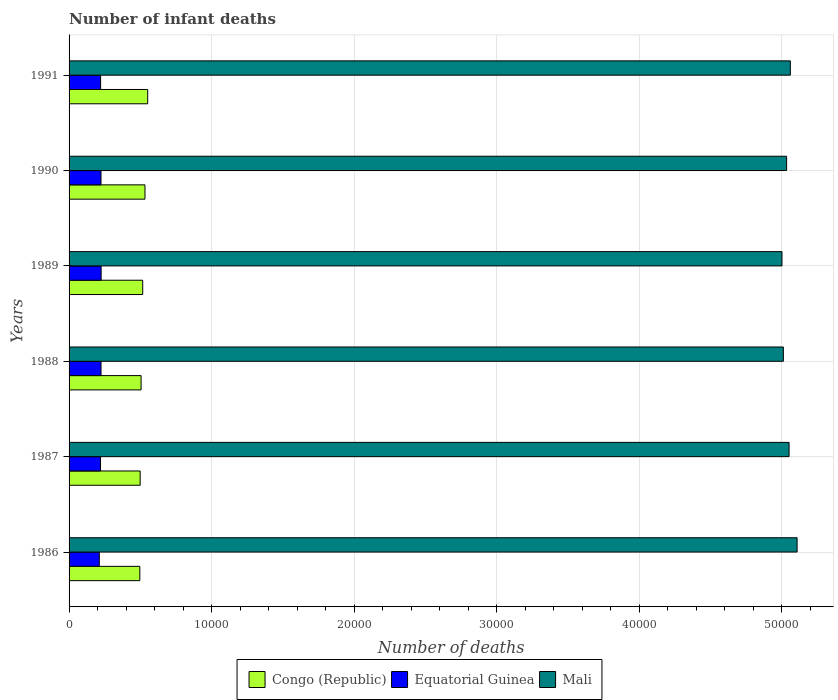How many different coloured bars are there?
Provide a succinct answer. 3. How many groups of bars are there?
Provide a succinct answer. 6. Are the number of bars per tick equal to the number of legend labels?
Provide a short and direct response. Yes. Are the number of bars on each tick of the Y-axis equal?
Ensure brevity in your answer.  Yes. How many bars are there on the 1st tick from the bottom?
Your answer should be very brief. 3. What is the label of the 5th group of bars from the top?
Give a very brief answer. 1987. In how many cases, is the number of bars for a given year not equal to the number of legend labels?
Provide a short and direct response. 0. What is the number of infant deaths in Congo (Republic) in 1988?
Your answer should be compact. 5053. Across all years, what is the maximum number of infant deaths in Mali?
Keep it short and to the point. 5.11e+04. Across all years, what is the minimum number of infant deaths in Equatorial Guinea?
Provide a succinct answer. 2121. In which year was the number of infant deaths in Mali maximum?
Provide a succinct answer. 1986. In which year was the number of infant deaths in Equatorial Guinea minimum?
Give a very brief answer. 1986. What is the total number of infant deaths in Mali in the graph?
Your answer should be compact. 3.03e+05. What is the difference between the number of infant deaths in Mali in 1987 and that in 1991?
Give a very brief answer. -88. What is the difference between the number of infant deaths in Congo (Republic) in 1990 and the number of infant deaths in Equatorial Guinea in 1987?
Keep it short and to the point. 3119. What is the average number of infant deaths in Mali per year?
Offer a very short reply. 5.04e+04. In the year 1991, what is the difference between the number of infant deaths in Mali and number of infant deaths in Equatorial Guinea?
Give a very brief answer. 4.84e+04. In how many years, is the number of infant deaths in Mali greater than 8000 ?
Give a very brief answer. 6. What is the ratio of the number of infant deaths in Mali in 1987 to that in 1989?
Your response must be concise. 1.01. Is the difference between the number of infant deaths in Mali in 1986 and 1990 greater than the difference between the number of infant deaths in Equatorial Guinea in 1986 and 1990?
Provide a short and direct response. Yes. What is the difference between the highest and the second highest number of infant deaths in Congo (Republic)?
Your answer should be very brief. 192. What is the difference between the highest and the lowest number of infant deaths in Equatorial Guinea?
Your response must be concise. 128. What does the 1st bar from the top in 1988 represents?
Keep it short and to the point. Mali. What does the 3rd bar from the bottom in 1988 represents?
Your answer should be compact. Mali. What is the difference between two consecutive major ticks on the X-axis?
Your answer should be very brief. 10000. Are the values on the major ticks of X-axis written in scientific E-notation?
Ensure brevity in your answer.  No. Does the graph contain any zero values?
Offer a terse response. No. Does the graph contain grids?
Your response must be concise. Yes. Where does the legend appear in the graph?
Provide a succinct answer. Bottom center. How many legend labels are there?
Ensure brevity in your answer.  3. How are the legend labels stacked?
Ensure brevity in your answer.  Horizontal. What is the title of the graph?
Your answer should be compact. Number of infant deaths. Does "Antigua and Barbuda" appear as one of the legend labels in the graph?
Give a very brief answer. No. What is the label or title of the X-axis?
Your answer should be compact. Number of deaths. What is the label or title of the Y-axis?
Your answer should be compact. Years. What is the Number of deaths in Congo (Republic) in 1986?
Ensure brevity in your answer.  4964. What is the Number of deaths in Equatorial Guinea in 1986?
Your response must be concise. 2121. What is the Number of deaths of Mali in 1986?
Provide a succinct answer. 5.11e+04. What is the Number of deaths of Congo (Republic) in 1987?
Provide a short and direct response. 4988. What is the Number of deaths of Equatorial Guinea in 1987?
Offer a very short reply. 2206. What is the Number of deaths of Mali in 1987?
Offer a very short reply. 5.05e+04. What is the Number of deaths in Congo (Republic) in 1988?
Your answer should be very brief. 5053. What is the Number of deaths in Equatorial Guinea in 1988?
Ensure brevity in your answer.  2243. What is the Number of deaths in Mali in 1988?
Make the answer very short. 5.01e+04. What is the Number of deaths of Congo (Republic) in 1989?
Your answer should be very brief. 5166. What is the Number of deaths of Equatorial Guinea in 1989?
Provide a succinct answer. 2249. What is the Number of deaths in Mali in 1989?
Your answer should be compact. 5.00e+04. What is the Number of deaths of Congo (Republic) in 1990?
Ensure brevity in your answer.  5325. What is the Number of deaths in Equatorial Guinea in 1990?
Make the answer very short. 2240. What is the Number of deaths in Mali in 1990?
Make the answer very short. 5.03e+04. What is the Number of deaths of Congo (Republic) in 1991?
Provide a succinct answer. 5517. What is the Number of deaths in Equatorial Guinea in 1991?
Ensure brevity in your answer.  2213. What is the Number of deaths in Mali in 1991?
Offer a terse response. 5.06e+04. Across all years, what is the maximum Number of deaths in Congo (Republic)?
Ensure brevity in your answer.  5517. Across all years, what is the maximum Number of deaths in Equatorial Guinea?
Keep it short and to the point. 2249. Across all years, what is the maximum Number of deaths of Mali?
Your answer should be compact. 5.11e+04. Across all years, what is the minimum Number of deaths of Congo (Republic)?
Offer a terse response. 4964. Across all years, what is the minimum Number of deaths in Equatorial Guinea?
Your answer should be compact. 2121. Across all years, what is the minimum Number of deaths in Mali?
Keep it short and to the point. 5.00e+04. What is the total Number of deaths of Congo (Republic) in the graph?
Offer a terse response. 3.10e+04. What is the total Number of deaths of Equatorial Guinea in the graph?
Provide a short and direct response. 1.33e+04. What is the total Number of deaths in Mali in the graph?
Make the answer very short. 3.03e+05. What is the difference between the Number of deaths of Congo (Republic) in 1986 and that in 1987?
Your response must be concise. -24. What is the difference between the Number of deaths of Equatorial Guinea in 1986 and that in 1987?
Ensure brevity in your answer.  -85. What is the difference between the Number of deaths of Mali in 1986 and that in 1987?
Offer a very short reply. 562. What is the difference between the Number of deaths in Congo (Republic) in 1986 and that in 1988?
Keep it short and to the point. -89. What is the difference between the Number of deaths of Equatorial Guinea in 1986 and that in 1988?
Provide a short and direct response. -122. What is the difference between the Number of deaths in Mali in 1986 and that in 1988?
Ensure brevity in your answer.  964. What is the difference between the Number of deaths of Congo (Republic) in 1986 and that in 1989?
Offer a terse response. -202. What is the difference between the Number of deaths in Equatorial Guinea in 1986 and that in 1989?
Your response must be concise. -128. What is the difference between the Number of deaths in Mali in 1986 and that in 1989?
Your answer should be compact. 1060. What is the difference between the Number of deaths in Congo (Republic) in 1986 and that in 1990?
Keep it short and to the point. -361. What is the difference between the Number of deaths in Equatorial Guinea in 1986 and that in 1990?
Give a very brief answer. -119. What is the difference between the Number of deaths of Mali in 1986 and that in 1990?
Your answer should be very brief. 734. What is the difference between the Number of deaths in Congo (Republic) in 1986 and that in 1991?
Provide a short and direct response. -553. What is the difference between the Number of deaths of Equatorial Guinea in 1986 and that in 1991?
Offer a terse response. -92. What is the difference between the Number of deaths of Mali in 1986 and that in 1991?
Make the answer very short. 474. What is the difference between the Number of deaths in Congo (Republic) in 1987 and that in 1988?
Your answer should be very brief. -65. What is the difference between the Number of deaths in Equatorial Guinea in 1987 and that in 1988?
Offer a terse response. -37. What is the difference between the Number of deaths of Mali in 1987 and that in 1988?
Provide a short and direct response. 402. What is the difference between the Number of deaths in Congo (Republic) in 1987 and that in 1989?
Offer a terse response. -178. What is the difference between the Number of deaths of Equatorial Guinea in 1987 and that in 1989?
Make the answer very short. -43. What is the difference between the Number of deaths in Mali in 1987 and that in 1989?
Your answer should be very brief. 498. What is the difference between the Number of deaths of Congo (Republic) in 1987 and that in 1990?
Provide a short and direct response. -337. What is the difference between the Number of deaths of Equatorial Guinea in 1987 and that in 1990?
Your answer should be compact. -34. What is the difference between the Number of deaths in Mali in 1987 and that in 1990?
Keep it short and to the point. 172. What is the difference between the Number of deaths of Congo (Republic) in 1987 and that in 1991?
Provide a succinct answer. -529. What is the difference between the Number of deaths in Equatorial Guinea in 1987 and that in 1991?
Your answer should be compact. -7. What is the difference between the Number of deaths in Mali in 1987 and that in 1991?
Give a very brief answer. -88. What is the difference between the Number of deaths of Congo (Republic) in 1988 and that in 1989?
Your response must be concise. -113. What is the difference between the Number of deaths in Equatorial Guinea in 1988 and that in 1989?
Offer a very short reply. -6. What is the difference between the Number of deaths of Mali in 1988 and that in 1989?
Your answer should be compact. 96. What is the difference between the Number of deaths in Congo (Republic) in 1988 and that in 1990?
Offer a terse response. -272. What is the difference between the Number of deaths of Mali in 1988 and that in 1990?
Provide a succinct answer. -230. What is the difference between the Number of deaths of Congo (Republic) in 1988 and that in 1991?
Make the answer very short. -464. What is the difference between the Number of deaths of Mali in 1988 and that in 1991?
Keep it short and to the point. -490. What is the difference between the Number of deaths of Congo (Republic) in 1989 and that in 1990?
Keep it short and to the point. -159. What is the difference between the Number of deaths of Mali in 1989 and that in 1990?
Provide a short and direct response. -326. What is the difference between the Number of deaths of Congo (Republic) in 1989 and that in 1991?
Offer a very short reply. -351. What is the difference between the Number of deaths of Equatorial Guinea in 1989 and that in 1991?
Provide a succinct answer. 36. What is the difference between the Number of deaths in Mali in 1989 and that in 1991?
Provide a short and direct response. -586. What is the difference between the Number of deaths in Congo (Republic) in 1990 and that in 1991?
Provide a succinct answer. -192. What is the difference between the Number of deaths of Mali in 1990 and that in 1991?
Provide a short and direct response. -260. What is the difference between the Number of deaths of Congo (Republic) in 1986 and the Number of deaths of Equatorial Guinea in 1987?
Make the answer very short. 2758. What is the difference between the Number of deaths in Congo (Republic) in 1986 and the Number of deaths in Mali in 1987?
Keep it short and to the point. -4.56e+04. What is the difference between the Number of deaths in Equatorial Guinea in 1986 and the Number of deaths in Mali in 1987?
Give a very brief answer. -4.84e+04. What is the difference between the Number of deaths in Congo (Republic) in 1986 and the Number of deaths in Equatorial Guinea in 1988?
Your answer should be compact. 2721. What is the difference between the Number of deaths of Congo (Republic) in 1986 and the Number of deaths of Mali in 1988?
Make the answer very short. -4.52e+04. What is the difference between the Number of deaths in Equatorial Guinea in 1986 and the Number of deaths in Mali in 1988?
Offer a terse response. -4.80e+04. What is the difference between the Number of deaths of Congo (Republic) in 1986 and the Number of deaths of Equatorial Guinea in 1989?
Make the answer very short. 2715. What is the difference between the Number of deaths of Congo (Republic) in 1986 and the Number of deaths of Mali in 1989?
Keep it short and to the point. -4.51e+04. What is the difference between the Number of deaths in Equatorial Guinea in 1986 and the Number of deaths in Mali in 1989?
Offer a terse response. -4.79e+04. What is the difference between the Number of deaths of Congo (Republic) in 1986 and the Number of deaths of Equatorial Guinea in 1990?
Your response must be concise. 2724. What is the difference between the Number of deaths of Congo (Republic) in 1986 and the Number of deaths of Mali in 1990?
Ensure brevity in your answer.  -4.54e+04. What is the difference between the Number of deaths in Equatorial Guinea in 1986 and the Number of deaths in Mali in 1990?
Ensure brevity in your answer.  -4.82e+04. What is the difference between the Number of deaths of Congo (Republic) in 1986 and the Number of deaths of Equatorial Guinea in 1991?
Make the answer very short. 2751. What is the difference between the Number of deaths in Congo (Republic) in 1986 and the Number of deaths in Mali in 1991?
Keep it short and to the point. -4.56e+04. What is the difference between the Number of deaths in Equatorial Guinea in 1986 and the Number of deaths in Mali in 1991?
Ensure brevity in your answer.  -4.85e+04. What is the difference between the Number of deaths of Congo (Republic) in 1987 and the Number of deaths of Equatorial Guinea in 1988?
Your answer should be compact. 2745. What is the difference between the Number of deaths in Congo (Republic) in 1987 and the Number of deaths in Mali in 1988?
Provide a short and direct response. -4.51e+04. What is the difference between the Number of deaths in Equatorial Guinea in 1987 and the Number of deaths in Mali in 1988?
Make the answer very short. -4.79e+04. What is the difference between the Number of deaths of Congo (Republic) in 1987 and the Number of deaths of Equatorial Guinea in 1989?
Your answer should be compact. 2739. What is the difference between the Number of deaths of Congo (Republic) in 1987 and the Number of deaths of Mali in 1989?
Provide a short and direct response. -4.50e+04. What is the difference between the Number of deaths in Equatorial Guinea in 1987 and the Number of deaths in Mali in 1989?
Keep it short and to the point. -4.78e+04. What is the difference between the Number of deaths of Congo (Republic) in 1987 and the Number of deaths of Equatorial Guinea in 1990?
Keep it short and to the point. 2748. What is the difference between the Number of deaths in Congo (Republic) in 1987 and the Number of deaths in Mali in 1990?
Offer a very short reply. -4.54e+04. What is the difference between the Number of deaths in Equatorial Guinea in 1987 and the Number of deaths in Mali in 1990?
Give a very brief answer. -4.81e+04. What is the difference between the Number of deaths in Congo (Republic) in 1987 and the Number of deaths in Equatorial Guinea in 1991?
Your answer should be compact. 2775. What is the difference between the Number of deaths of Congo (Republic) in 1987 and the Number of deaths of Mali in 1991?
Your response must be concise. -4.56e+04. What is the difference between the Number of deaths in Equatorial Guinea in 1987 and the Number of deaths in Mali in 1991?
Your response must be concise. -4.84e+04. What is the difference between the Number of deaths of Congo (Republic) in 1988 and the Number of deaths of Equatorial Guinea in 1989?
Make the answer very short. 2804. What is the difference between the Number of deaths of Congo (Republic) in 1988 and the Number of deaths of Mali in 1989?
Offer a terse response. -4.50e+04. What is the difference between the Number of deaths of Equatorial Guinea in 1988 and the Number of deaths of Mali in 1989?
Offer a terse response. -4.78e+04. What is the difference between the Number of deaths of Congo (Republic) in 1988 and the Number of deaths of Equatorial Guinea in 1990?
Your answer should be very brief. 2813. What is the difference between the Number of deaths in Congo (Republic) in 1988 and the Number of deaths in Mali in 1990?
Offer a terse response. -4.53e+04. What is the difference between the Number of deaths in Equatorial Guinea in 1988 and the Number of deaths in Mali in 1990?
Offer a very short reply. -4.81e+04. What is the difference between the Number of deaths of Congo (Republic) in 1988 and the Number of deaths of Equatorial Guinea in 1991?
Offer a terse response. 2840. What is the difference between the Number of deaths in Congo (Republic) in 1988 and the Number of deaths in Mali in 1991?
Your answer should be compact. -4.56e+04. What is the difference between the Number of deaths in Equatorial Guinea in 1988 and the Number of deaths in Mali in 1991?
Ensure brevity in your answer.  -4.84e+04. What is the difference between the Number of deaths of Congo (Republic) in 1989 and the Number of deaths of Equatorial Guinea in 1990?
Offer a very short reply. 2926. What is the difference between the Number of deaths in Congo (Republic) in 1989 and the Number of deaths in Mali in 1990?
Your response must be concise. -4.52e+04. What is the difference between the Number of deaths of Equatorial Guinea in 1989 and the Number of deaths of Mali in 1990?
Provide a short and direct response. -4.81e+04. What is the difference between the Number of deaths of Congo (Republic) in 1989 and the Number of deaths of Equatorial Guinea in 1991?
Your answer should be compact. 2953. What is the difference between the Number of deaths of Congo (Republic) in 1989 and the Number of deaths of Mali in 1991?
Make the answer very short. -4.54e+04. What is the difference between the Number of deaths of Equatorial Guinea in 1989 and the Number of deaths of Mali in 1991?
Your answer should be very brief. -4.84e+04. What is the difference between the Number of deaths of Congo (Republic) in 1990 and the Number of deaths of Equatorial Guinea in 1991?
Your response must be concise. 3112. What is the difference between the Number of deaths of Congo (Republic) in 1990 and the Number of deaths of Mali in 1991?
Your response must be concise. -4.53e+04. What is the difference between the Number of deaths in Equatorial Guinea in 1990 and the Number of deaths in Mali in 1991?
Offer a very short reply. -4.84e+04. What is the average Number of deaths of Congo (Republic) per year?
Your answer should be compact. 5168.83. What is the average Number of deaths of Equatorial Guinea per year?
Provide a succinct answer. 2212. What is the average Number of deaths of Mali per year?
Keep it short and to the point. 5.04e+04. In the year 1986, what is the difference between the Number of deaths in Congo (Republic) and Number of deaths in Equatorial Guinea?
Provide a short and direct response. 2843. In the year 1986, what is the difference between the Number of deaths of Congo (Republic) and Number of deaths of Mali?
Your answer should be very brief. -4.61e+04. In the year 1986, what is the difference between the Number of deaths of Equatorial Guinea and Number of deaths of Mali?
Keep it short and to the point. -4.90e+04. In the year 1987, what is the difference between the Number of deaths of Congo (Republic) and Number of deaths of Equatorial Guinea?
Offer a very short reply. 2782. In the year 1987, what is the difference between the Number of deaths of Congo (Republic) and Number of deaths of Mali?
Ensure brevity in your answer.  -4.55e+04. In the year 1987, what is the difference between the Number of deaths in Equatorial Guinea and Number of deaths in Mali?
Your response must be concise. -4.83e+04. In the year 1988, what is the difference between the Number of deaths of Congo (Republic) and Number of deaths of Equatorial Guinea?
Offer a very short reply. 2810. In the year 1988, what is the difference between the Number of deaths in Congo (Republic) and Number of deaths in Mali?
Your answer should be compact. -4.51e+04. In the year 1988, what is the difference between the Number of deaths in Equatorial Guinea and Number of deaths in Mali?
Give a very brief answer. -4.79e+04. In the year 1989, what is the difference between the Number of deaths in Congo (Republic) and Number of deaths in Equatorial Guinea?
Provide a succinct answer. 2917. In the year 1989, what is the difference between the Number of deaths in Congo (Republic) and Number of deaths in Mali?
Your answer should be compact. -4.49e+04. In the year 1989, what is the difference between the Number of deaths of Equatorial Guinea and Number of deaths of Mali?
Provide a short and direct response. -4.78e+04. In the year 1990, what is the difference between the Number of deaths in Congo (Republic) and Number of deaths in Equatorial Guinea?
Ensure brevity in your answer.  3085. In the year 1990, what is the difference between the Number of deaths of Congo (Republic) and Number of deaths of Mali?
Offer a terse response. -4.50e+04. In the year 1990, what is the difference between the Number of deaths of Equatorial Guinea and Number of deaths of Mali?
Ensure brevity in your answer.  -4.81e+04. In the year 1991, what is the difference between the Number of deaths in Congo (Republic) and Number of deaths in Equatorial Guinea?
Offer a very short reply. 3304. In the year 1991, what is the difference between the Number of deaths in Congo (Republic) and Number of deaths in Mali?
Offer a very short reply. -4.51e+04. In the year 1991, what is the difference between the Number of deaths of Equatorial Guinea and Number of deaths of Mali?
Offer a terse response. -4.84e+04. What is the ratio of the Number of deaths of Congo (Republic) in 1986 to that in 1987?
Your response must be concise. 1. What is the ratio of the Number of deaths in Equatorial Guinea in 1986 to that in 1987?
Provide a short and direct response. 0.96. What is the ratio of the Number of deaths in Mali in 1986 to that in 1987?
Your response must be concise. 1.01. What is the ratio of the Number of deaths in Congo (Republic) in 1986 to that in 1988?
Ensure brevity in your answer.  0.98. What is the ratio of the Number of deaths in Equatorial Guinea in 1986 to that in 1988?
Provide a succinct answer. 0.95. What is the ratio of the Number of deaths of Mali in 1986 to that in 1988?
Your answer should be very brief. 1.02. What is the ratio of the Number of deaths of Congo (Republic) in 1986 to that in 1989?
Offer a terse response. 0.96. What is the ratio of the Number of deaths in Equatorial Guinea in 1986 to that in 1989?
Offer a very short reply. 0.94. What is the ratio of the Number of deaths of Mali in 1986 to that in 1989?
Offer a terse response. 1.02. What is the ratio of the Number of deaths of Congo (Republic) in 1986 to that in 1990?
Offer a terse response. 0.93. What is the ratio of the Number of deaths of Equatorial Guinea in 1986 to that in 1990?
Keep it short and to the point. 0.95. What is the ratio of the Number of deaths in Mali in 1986 to that in 1990?
Ensure brevity in your answer.  1.01. What is the ratio of the Number of deaths in Congo (Republic) in 1986 to that in 1991?
Provide a short and direct response. 0.9. What is the ratio of the Number of deaths in Equatorial Guinea in 1986 to that in 1991?
Offer a terse response. 0.96. What is the ratio of the Number of deaths of Mali in 1986 to that in 1991?
Your response must be concise. 1.01. What is the ratio of the Number of deaths of Congo (Republic) in 1987 to that in 1988?
Ensure brevity in your answer.  0.99. What is the ratio of the Number of deaths of Equatorial Guinea in 1987 to that in 1988?
Provide a succinct answer. 0.98. What is the ratio of the Number of deaths in Congo (Republic) in 1987 to that in 1989?
Give a very brief answer. 0.97. What is the ratio of the Number of deaths of Equatorial Guinea in 1987 to that in 1989?
Give a very brief answer. 0.98. What is the ratio of the Number of deaths of Mali in 1987 to that in 1989?
Your answer should be compact. 1.01. What is the ratio of the Number of deaths in Congo (Republic) in 1987 to that in 1990?
Make the answer very short. 0.94. What is the ratio of the Number of deaths of Equatorial Guinea in 1987 to that in 1990?
Provide a short and direct response. 0.98. What is the ratio of the Number of deaths of Mali in 1987 to that in 1990?
Your response must be concise. 1. What is the ratio of the Number of deaths in Congo (Republic) in 1987 to that in 1991?
Your answer should be compact. 0.9. What is the ratio of the Number of deaths in Equatorial Guinea in 1987 to that in 1991?
Your response must be concise. 1. What is the ratio of the Number of deaths of Congo (Republic) in 1988 to that in 1989?
Your answer should be compact. 0.98. What is the ratio of the Number of deaths of Mali in 1988 to that in 1989?
Give a very brief answer. 1. What is the ratio of the Number of deaths of Congo (Republic) in 1988 to that in 1990?
Give a very brief answer. 0.95. What is the ratio of the Number of deaths of Equatorial Guinea in 1988 to that in 1990?
Your answer should be compact. 1. What is the ratio of the Number of deaths in Congo (Republic) in 1988 to that in 1991?
Provide a short and direct response. 0.92. What is the ratio of the Number of deaths of Equatorial Guinea in 1988 to that in 1991?
Provide a succinct answer. 1.01. What is the ratio of the Number of deaths in Mali in 1988 to that in 1991?
Give a very brief answer. 0.99. What is the ratio of the Number of deaths of Congo (Republic) in 1989 to that in 1990?
Offer a very short reply. 0.97. What is the ratio of the Number of deaths in Equatorial Guinea in 1989 to that in 1990?
Your answer should be compact. 1. What is the ratio of the Number of deaths in Mali in 1989 to that in 1990?
Ensure brevity in your answer.  0.99. What is the ratio of the Number of deaths of Congo (Republic) in 1989 to that in 1991?
Your answer should be compact. 0.94. What is the ratio of the Number of deaths of Equatorial Guinea in 1989 to that in 1991?
Make the answer very short. 1.02. What is the ratio of the Number of deaths of Mali in 1989 to that in 1991?
Keep it short and to the point. 0.99. What is the ratio of the Number of deaths in Congo (Republic) in 1990 to that in 1991?
Your answer should be very brief. 0.97. What is the ratio of the Number of deaths in Equatorial Guinea in 1990 to that in 1991?
Ensure brevity in your answer.  1.01. What is the ratio of the Number of deaths of Mali in 1990 to that in 1991?
Your answer should be very brief. 0.99. What is the difference between the highest and the second highest Number of deaths in Congo (Republic)?
Offer a terse response. 192. What is the difference between the highest and the second highest Number of deaths of Mali?
Your answer should be compact. 474. What is the difference between the highest and the lowest Number of deaths of Congo (Republic)?
Provide a succinct answer. 553. What is the difference between the highest and the lowest Number of deaths of Equatorial Guinea?
Make the answer very short. 128. What is the difference between the highest and the lowest Number of deaths of Mali?
Offer a terse response. 1060. 